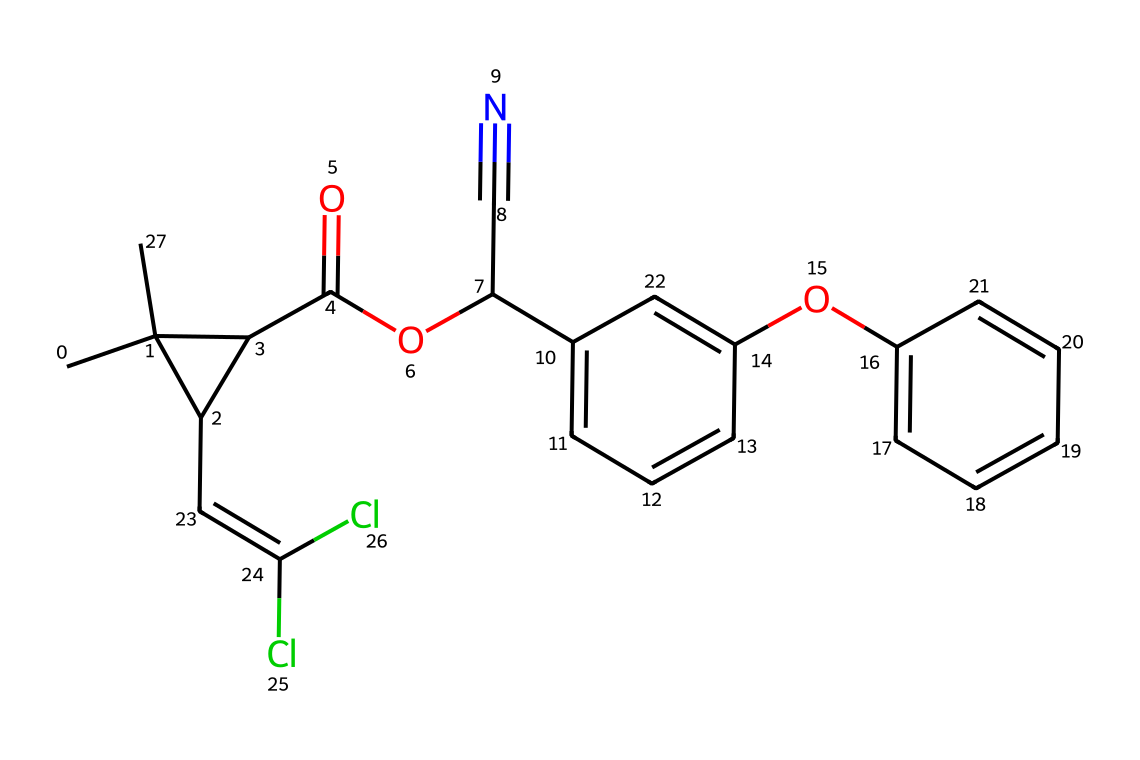How many carbon atoms are in this chemical? By analyzing the SMILES representation, I can count the carbon atoms. The displayed structure indicates multiple carbon atoms, where the 'C' represents carbon. In this molecule, there are 20 carbon atoms shown in various groups and molecular ends.
Answer: 20 What functional group is represented by "C(=O)O"? The part "C(=O)O" denotes a carboxyl group, characterized by a carbon atom double bonded to an oxygen atom and single bonded to a hydroxyl (-OH) group. This is typical for esters or acids, which are relevant in organic chemistry and can also be found in insecticides.
Answer: carboxyl Does this chemical structure suggest a ring structure? Upon examining the SMILES, the notation "C1" and "C" followed by parentheses indicates a cyclic structure. The "1" denotes the start of a ring, and since the "1" appears later again, it tells us where the ring closes. Therefore, we can confirm that there is a ring present in the molecule.
Answer: yes Is there a chloro group in this chemical? The "Cl" notation appearing twice in the structure indicates the presence of chlorine atoms, identifying them as chloro groups. The two occurrences imply that this molecule has two chloro groups within its structure.
Answer: yes What does the presence of a cyanide group (C#N) indicate about this chemical's properties? The presence of the cyanide group (depicted as "C#N") indicates that this chemical likely has increased toxicity. Cyanide is known for its acute toxicity, which often associates with pyrethroids and enhances their effectiveness as insecticides.
Answer: increased toxicity Are there aromatic rings in this chemical structure? The presence of lowercase 'c' in the structure indicates that there is at least one aromatic ring (specifically benzene rings), which are stable cyclic structures with alternating double bonds. The "c" represents aromatic carbon atoms. In this case, there are more than one aromatic ring connected to other parts of the molecule.
Answer: yes 